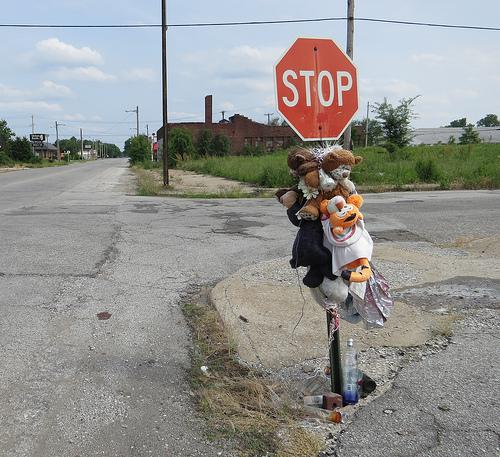Question: why is there a sign?
Choices:
A. Directions.
B. Instructions.
C. Omen.
D. Notification.
Answer with the letter. Answer: D Question: where is this scene?
Choices:
A. On the street.
B. On the road.
C. On the highway.
D. On the corner.
Answer with the letter. Answer: A Question: who is present?
Choices:
A. A few people.
B. No one.
C. One person.
D. Five kids.
Answer with the letter. Answer: B 